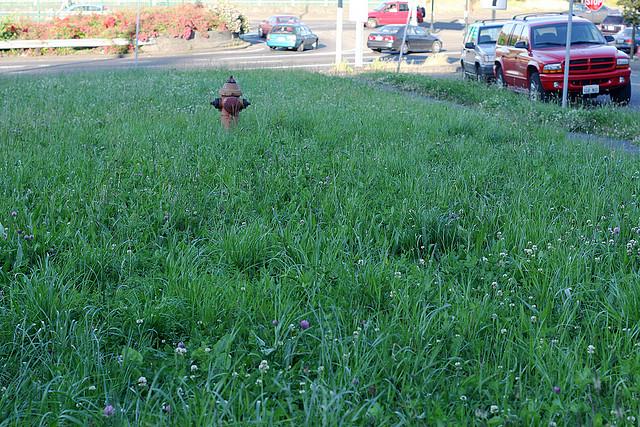Is there a balcony?
Write a very short answer. No. If a fire hose is only two feet long, can it reach the hydrant?
Quick response, please. No. Has the grass been mowed recently?
Short answer required. No. What is growing here?
Short answer required. Grass. Where is the path going?
Concise answer only. To street. Is this in Nature?
Concise answer only. Yes. What color is the 1st car?
Be succinct. Red. How many cars are parked across the street?
Concise answer only. 4. 